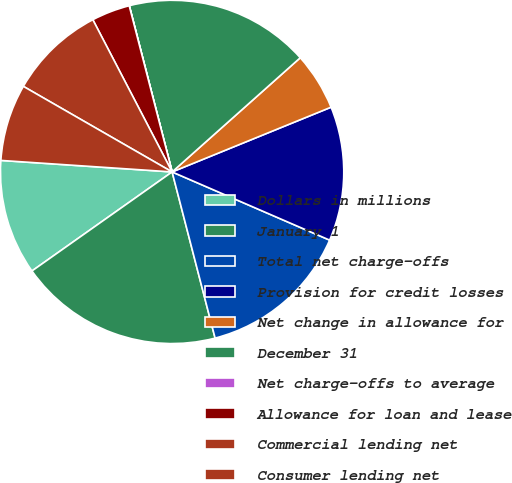<chart> <loc_0><loc_0><loc_500><loc_500><pie_chart><fcel>Dollars in millions<fcel>January 1<fcel>Total net charge-offs<fcel>Provision for credit losses<fcel>Net change in allowance for<fcel>December 31<fcel>Net charge-offs to average<fcel>Allowance for loan and lease<fcel>Commercial lending net<fcel>Consumer lending net<nl><fcel>10.86%<fcel>19.24%<fcel>14.47%<fcel>12.66%<fcel>5.43%<fcel>17.43%<fcel>0.01%<fcel>3.62%<fcel>9.05%<fcel>7.24%<nl></chart> 